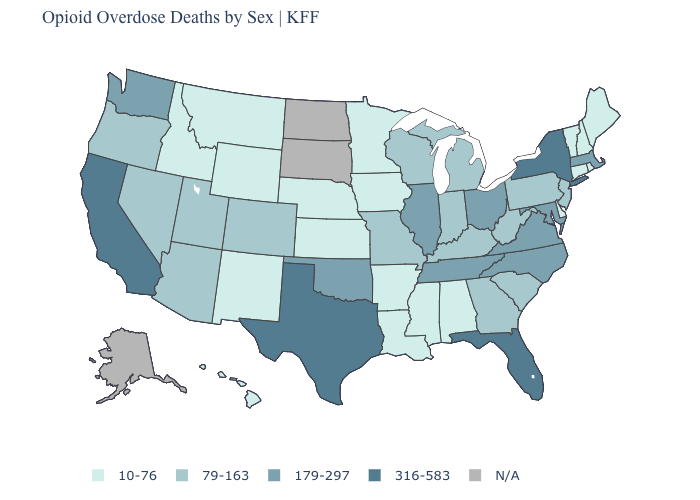What is the highest value in states that border Georgia?
Write a very short answer. 316-583. Name the states that have a value in the range 10-76?
Be succinct. Alabama, Arkansas, Connecticut, Delaware, Hawaii, Idaho, Iowa, Kansas, Louisiana, Maine, Minnesota, Mississippi, Montana, Nebraska, New Hampshire, New Mexico, Rhode Island, Vermont, Wyoming. What is the highest value in the USA?
Short answer required. 316-583. Does the first symbol in the legend represent the smallest category?
Be succinct. Yes. Among the states that border New Hampshire , which have the highest value?
Keep it brief. Massachusetts. Name the states that have a value in the range 316-583?
Write a very short answer. California, Florida, New York, Texas. Name the states that have a value in the range 179-297?
Give a very brief answer. Illinois, Maryland, Massachusetts, North Carolina, Ohio, Oklahoma, Tennessee, Virginia, Washington. Does the map have missing data?
Short answer required. Yes. What is the highest value in states that border Florida?
Short answer required. 79-163. What is the highest value in the USA?
Write a very short answer. 316-583. Does Arizona have the lowest value in the West?
Answer briefly. No. What is the value of Maine?
Keep it brief. 10-76. Does the map have missing data?
Keep it brief. Yes. What is the value of Connecticut?
Give a very brief answer. 10-76. 